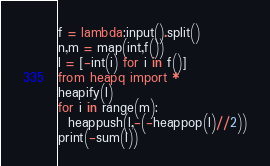Convert code to text. <code><loc_0><loc_0><loc_500><loc_500><_Python_>f = lambda:input().split()
n,m = map(int,f())
l = [-int(i) for i in f()]
from heapq import *
heapify(l)
for i in range(m):
  heappush(l,-(-heappop(l)//2))
print(-sum(l))</code> 